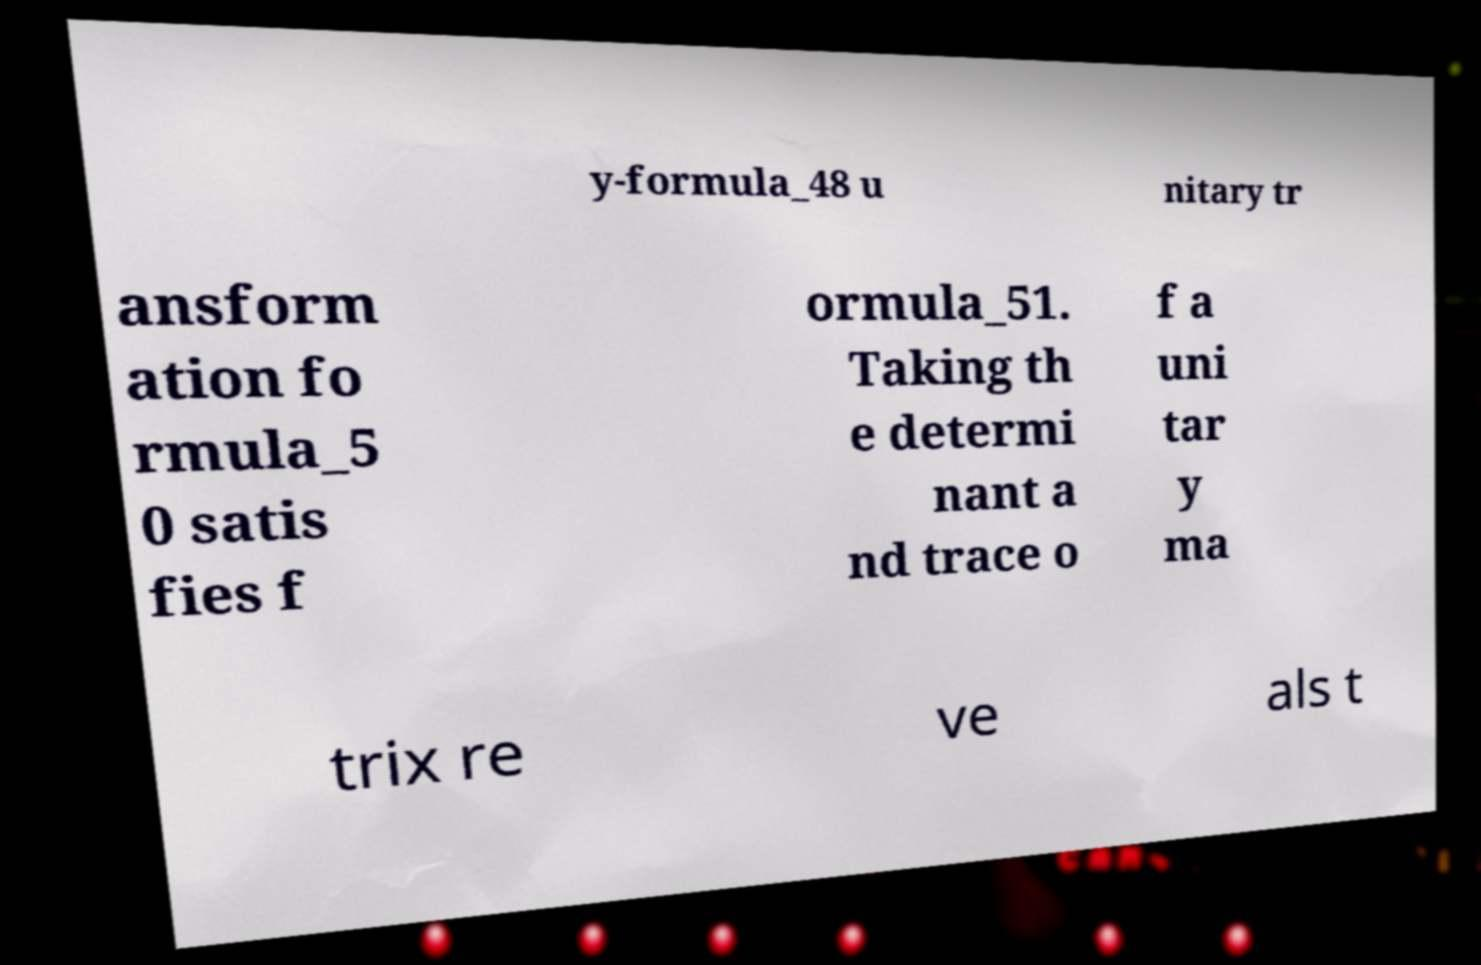Could you assist in decoding the text presented in this image and type it out clearly? y-formula_48 u nitary tr ansform ation fo rmula_5 0 satis fies f ormula_51. Taking th e determi nant a nd trace o f a uni tar y ma trix re ve als t 